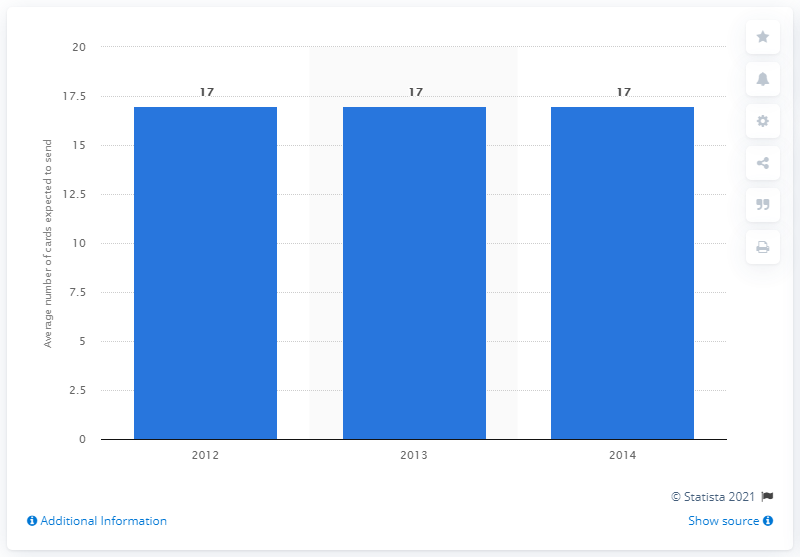Give some essential details in this illustration. UK consumers had planned to send approximately 17 Christmas cards in 2012, 2013, and 2014. 